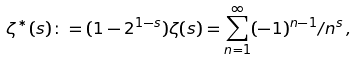<formula> <loc_0><loc_0><loc_500><loc_500>\zeta ^ { \ast } ( s ) \colon = ( 1 - 2 ^ { 1 - s } ) \zeta ( s ) = \sum _ { n = 1 } ^ { \infty } ( - 1 ) ^ { n - 1 } / n ^ { s } \, ,</formula> 